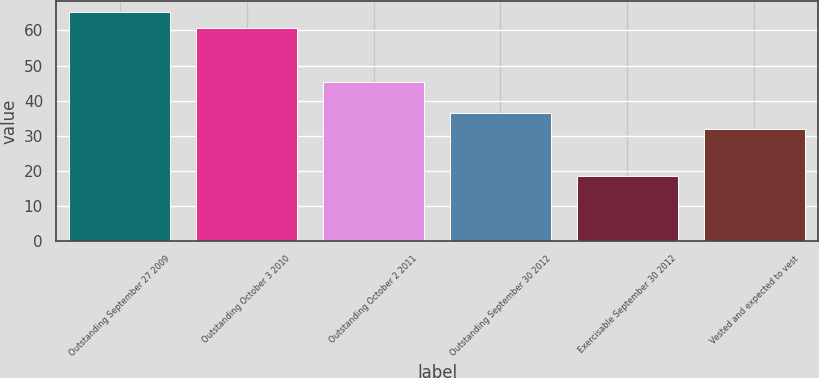Convert chart to OTSL. <chart><loc_0><loc_0><loc_500><loc_500><bar_chart><fcel>Outstanding September 27 2009<fcel>Outstanding October 3 2010<fcel>Outstanding October 2 2011<fcel>Outstanding September 30 2012<fcel>Exercisable September 30 2012<fcel>Vested and expected to vest<nl><fcel>65.22<fcel>60.7<fcel>45.3<fcel>36.52<fcel>18.4<fcel>32<nl></chart> 